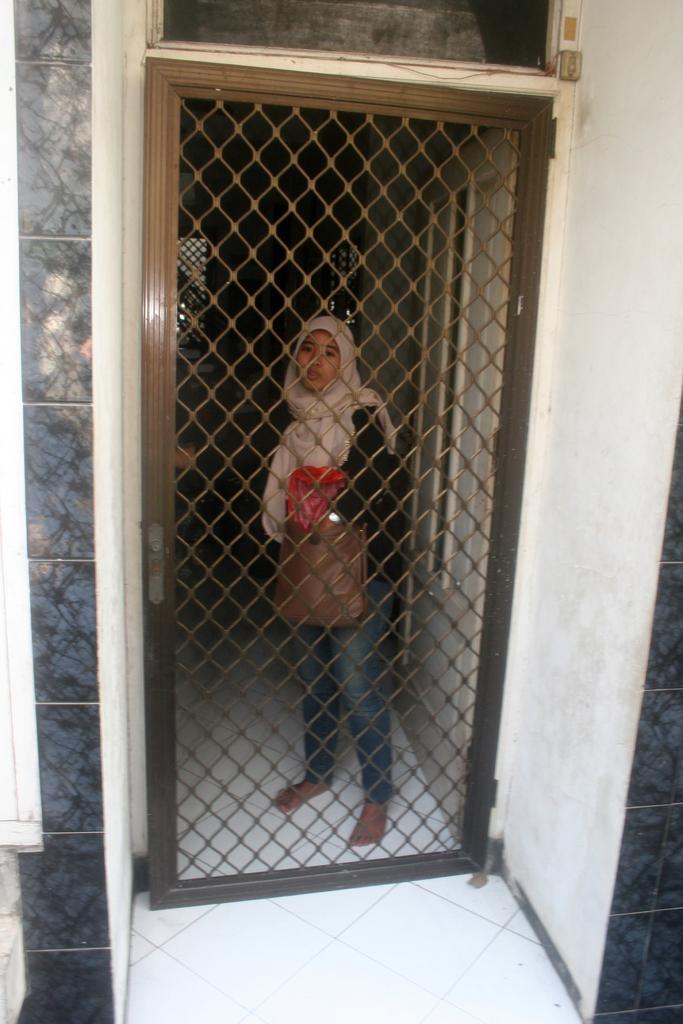Describe this image in one or two sentences. In this picture we can see a woman standing on the floor, mesh door and in the background we can see windows. 